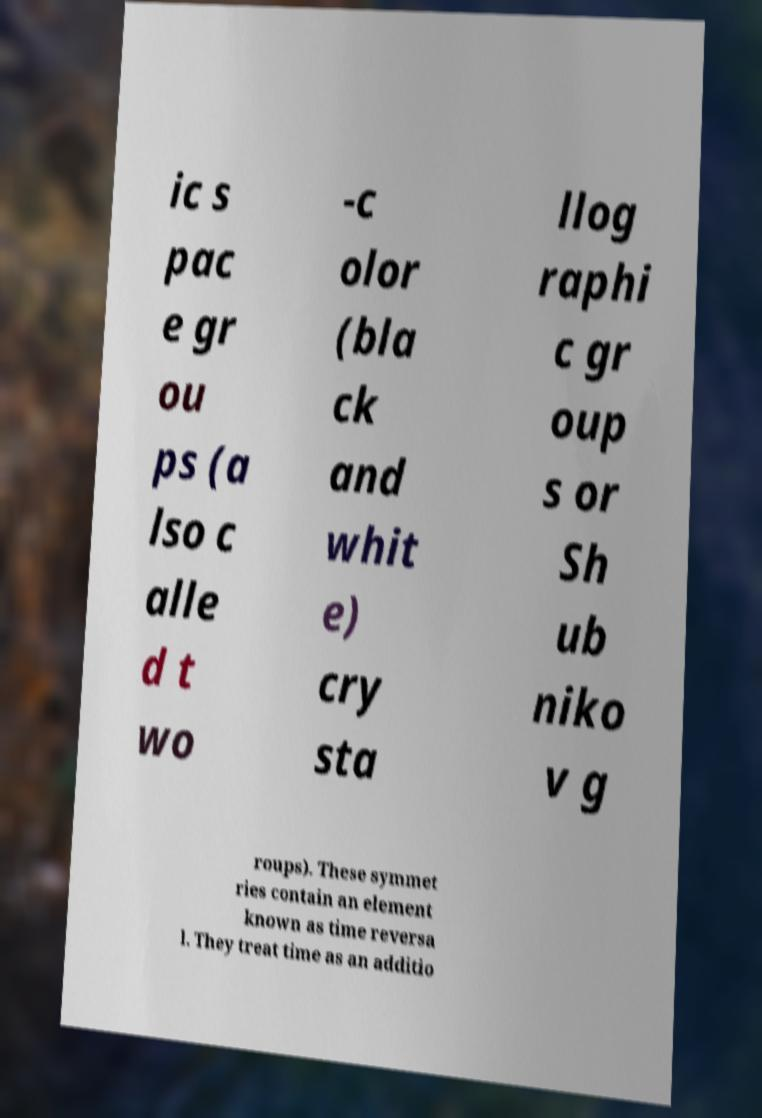Could you assist in decoding the text presented in this image and type it out clearly? ic s pac e gr ou ps (a lso c alle d t wo -c olor (bla ck and whit e) cry sta llog raphi c gr oup s or Sh ub niko v g roups). These symmet ries contain an element known as time reversa l. They treat time as an additio 